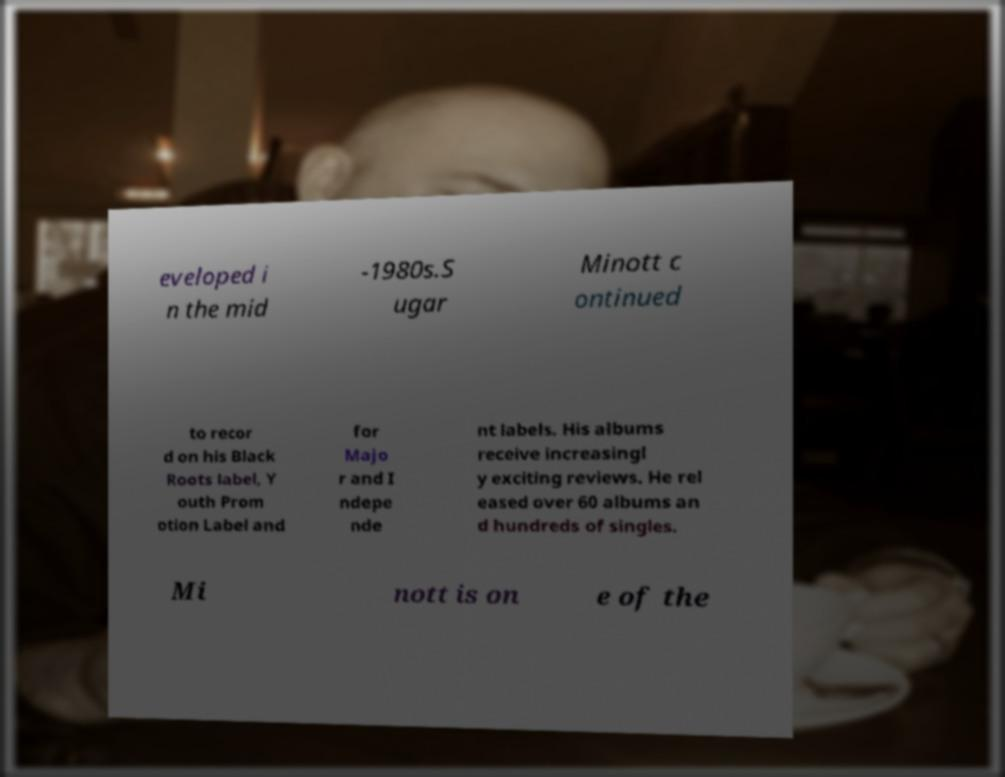Please identify and transcribe the text found in this image. eveloped i n the mid -1980s.S ugar Minott c ontinued to recor d on his Black Roots label, Y outh Prom otion Label and for Majo r and I ndepe nde nt labels. His albums receive increasingl y exciting reviews. He rel eased over 60 albums an d hundreds of singles. Mi nott is on e of the 